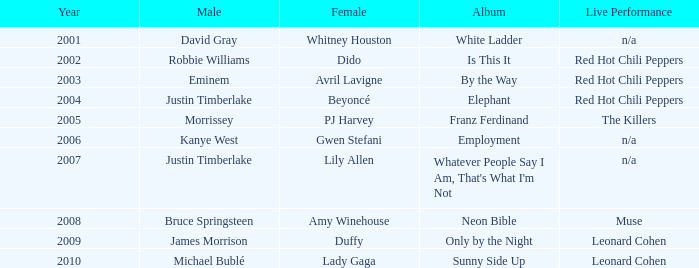Who is the male partner for amy winehouse? Bruce Springsteen. 